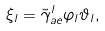Convert formula to latex. <formula><loc_0><loc_0><loc_500><loc_500>\xi _ { l } = \tilde { \gamma } _ { a e } ^ { l } \varphi _ { l } \vartheta _ { l } ,</formula> 